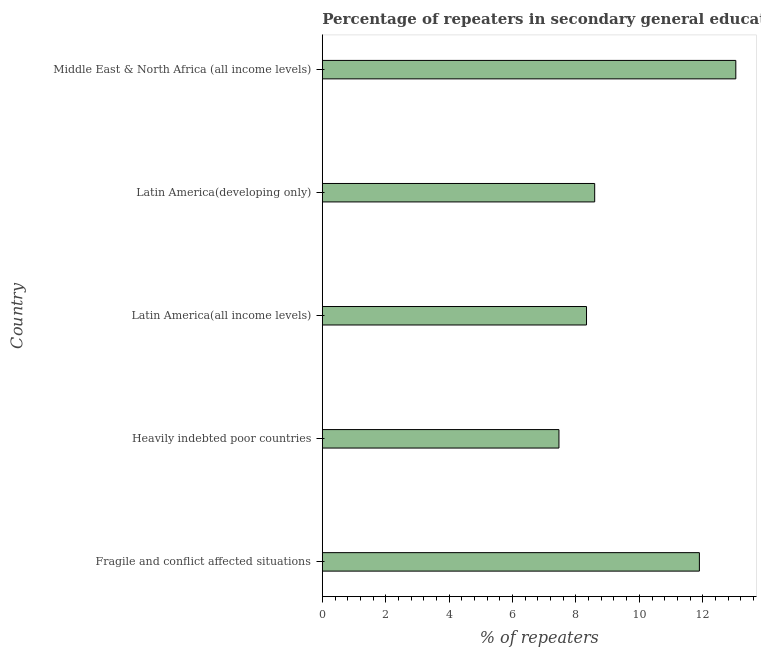Does the graph contain any zero values?
Offer a terse response. No. What is the title of the graph?
Keep it short and to the point. Percentage of repeaters in secondary general education of countries in the year 1972. What is the label or title of the X-axis?
Ensure brevity in your answer.  % of repeaters. What is the percentage of repeaters in Middle East & North Africa (all income levels)?
Your answer should be compact. 13.04. Across all countries, what is the maximum percentage of repeaters?
Offer a very short reply. 13.04. Across all countries, what is the minimum percentage of repeaters?
Offer a very short reply. 7.46. In which country was the percentage of repeaters maximum?
Keep it short and to the point. Middle East & North Africa (all income levels). In which country was the percentage of repeaters minimum?
Offer a terse response. Heavily indebted poor countries. What is the sum of the percentage of repeaters?
Make the answer very short. 49.33. What is the difference between the percentage of repeaters in Latin America(all income levels) and Middle East & North Africa (all income levels)?
Offer a very short reply. -4.71. What is the average percentage of repeaters per country?
Ensure brevity in your answer.  9.87. What is the median percentage of repeaters?
Make the answer very short. 8.59. In how many countries, is the percentage of repeaters greater than 6.4 %?
Provide a short and direct response. 5. What is the ratio of the percentage of repeaters in Latin America(all income levels) to that in Latin America(developing only)?
Your answer should be compact. 0.97. What is the difference between the highest and the second highest percentage of repeaters?
Give a very brief answer. 1.15. Is the sum of the percentage of repeaters in Heavily indebted poor countries and Latin America(developing only) greater than the maximum percentage of repeaters across all countries?
Your answer should be compact. Yes. What is the difference between the highest and the lowest percentage of repeaters?
Make the answer very short. 5.58. How many bars are there?
Keep it short and to the point. 5. Are all the bars in the graph horizontal?
Give a very brief answer. Yes. How many countries are there in the graph?
Make the answer very short. 5. What is the % of repeaters of Fragile and conflict affected situations?
Provide a succinct answer. 11.89. What is the % of repeaters in Heavily indebted poor countries?
Make the answer very short. 7.46. What is the % of repeaters in Latin America(all income levels)?
Ensure brevity in your answer.  8.33. What is the % of repeaters of Latin America(developing only)?
Provide a short and direct response. 8.59. What is the % of repeaters of Middle East & North Africa (all income levels)?
Make the answer very short. 13.04. What is the difference between the % of repeaters in Fragile and conflict affected situations and Heavily indebted poor countries?
Offer a very short reply. 4.43. What is the difference between the % of repeaters in Fragile and conflict affected situations and Latin America(all income levels)?
Your answer should be very brief. 3.56. What is the difference between the % of repeaters in Fragile and conflict affected situations and Latin America(developing only)?
Keep it short and to the point. 3.3. What is the difference between the % of repeaters in Fragile and conflict affected situations and Middle East & North Africa (all income levels)?
Provide a succinct answer. -1.15. What is the difference between the % of repeaters in Heavily indebted poor countries and Latin America(all income levels)?
Offer a very short reply. -0.87. What is the difference between the % of repeaters in Heavily indebted poor countries and Latin America(developing only)?
Provide a short and direct response. -1.13. What is the difference between the % of repeaters in Heavily indebted poor countries and Middle East & North Africa (all income levels)?
Provide a short and direct response. -5.58. What is the difference between the % of repeaters in Latin America(all income levels) and Latin America(developing only)?
Give a very brief answer. -0.26. What is the difference between the % of repeaters in Latin America(all income levels) and Middle East & North Africa (all income levels)?
Give a very brief answer. -4.71. What is the difference between the % of repeaters in Latin America(developing only) and Middle East & North Africa (all income levels)?
Make the answer very short. -4.45. What is the ratio of the % of repeaters in Fragile and conflict affected situations to that in Heavily indebted poor countries?
Your answer should be very brief. 1.59. What is the ratio of the % of repeaters in Fragile and conflict affected situations to that in Latin America(all income levels)?
Keep it short and to the point. 1.43. What is the ratio of the % of repeaters in Fragile and conflict affected situations to that in Latin America(developing only)?
Provide a short and direct response. 1.38. What is the ratio of the % of repeaters in Fragile and conflict affected situations to that in Middle East & North Africa (all income levels)?
Your response must be concise. 0.91. What is the ratio of the % of repeaters in Heavily indebted poor countries to that in Latin America(all income levels)?
Your answer should be compact. 0.9. What is the ratio of the % of repeaters in Heavily indebted poor countries to that in Latin America(developing only)?
Provide a short and direct response. 0.87. What is the ratio of the % of repeaters in Heavily indebted poor countries to that in Middle East & North Africa (all income levels)?
Offer a very short reply. 0.57. What is the ratio of the % of repeaters in Latin America(all income levels) to that in Middle East & North Africa (all income levels)?
Your answer should be very brief. 0.64. What is the ratio of the % of repeaters in Latin America(developing only) to that in Middle East & North Africa (all income levels)?
Ensure brevity in your answer.  0.66. 